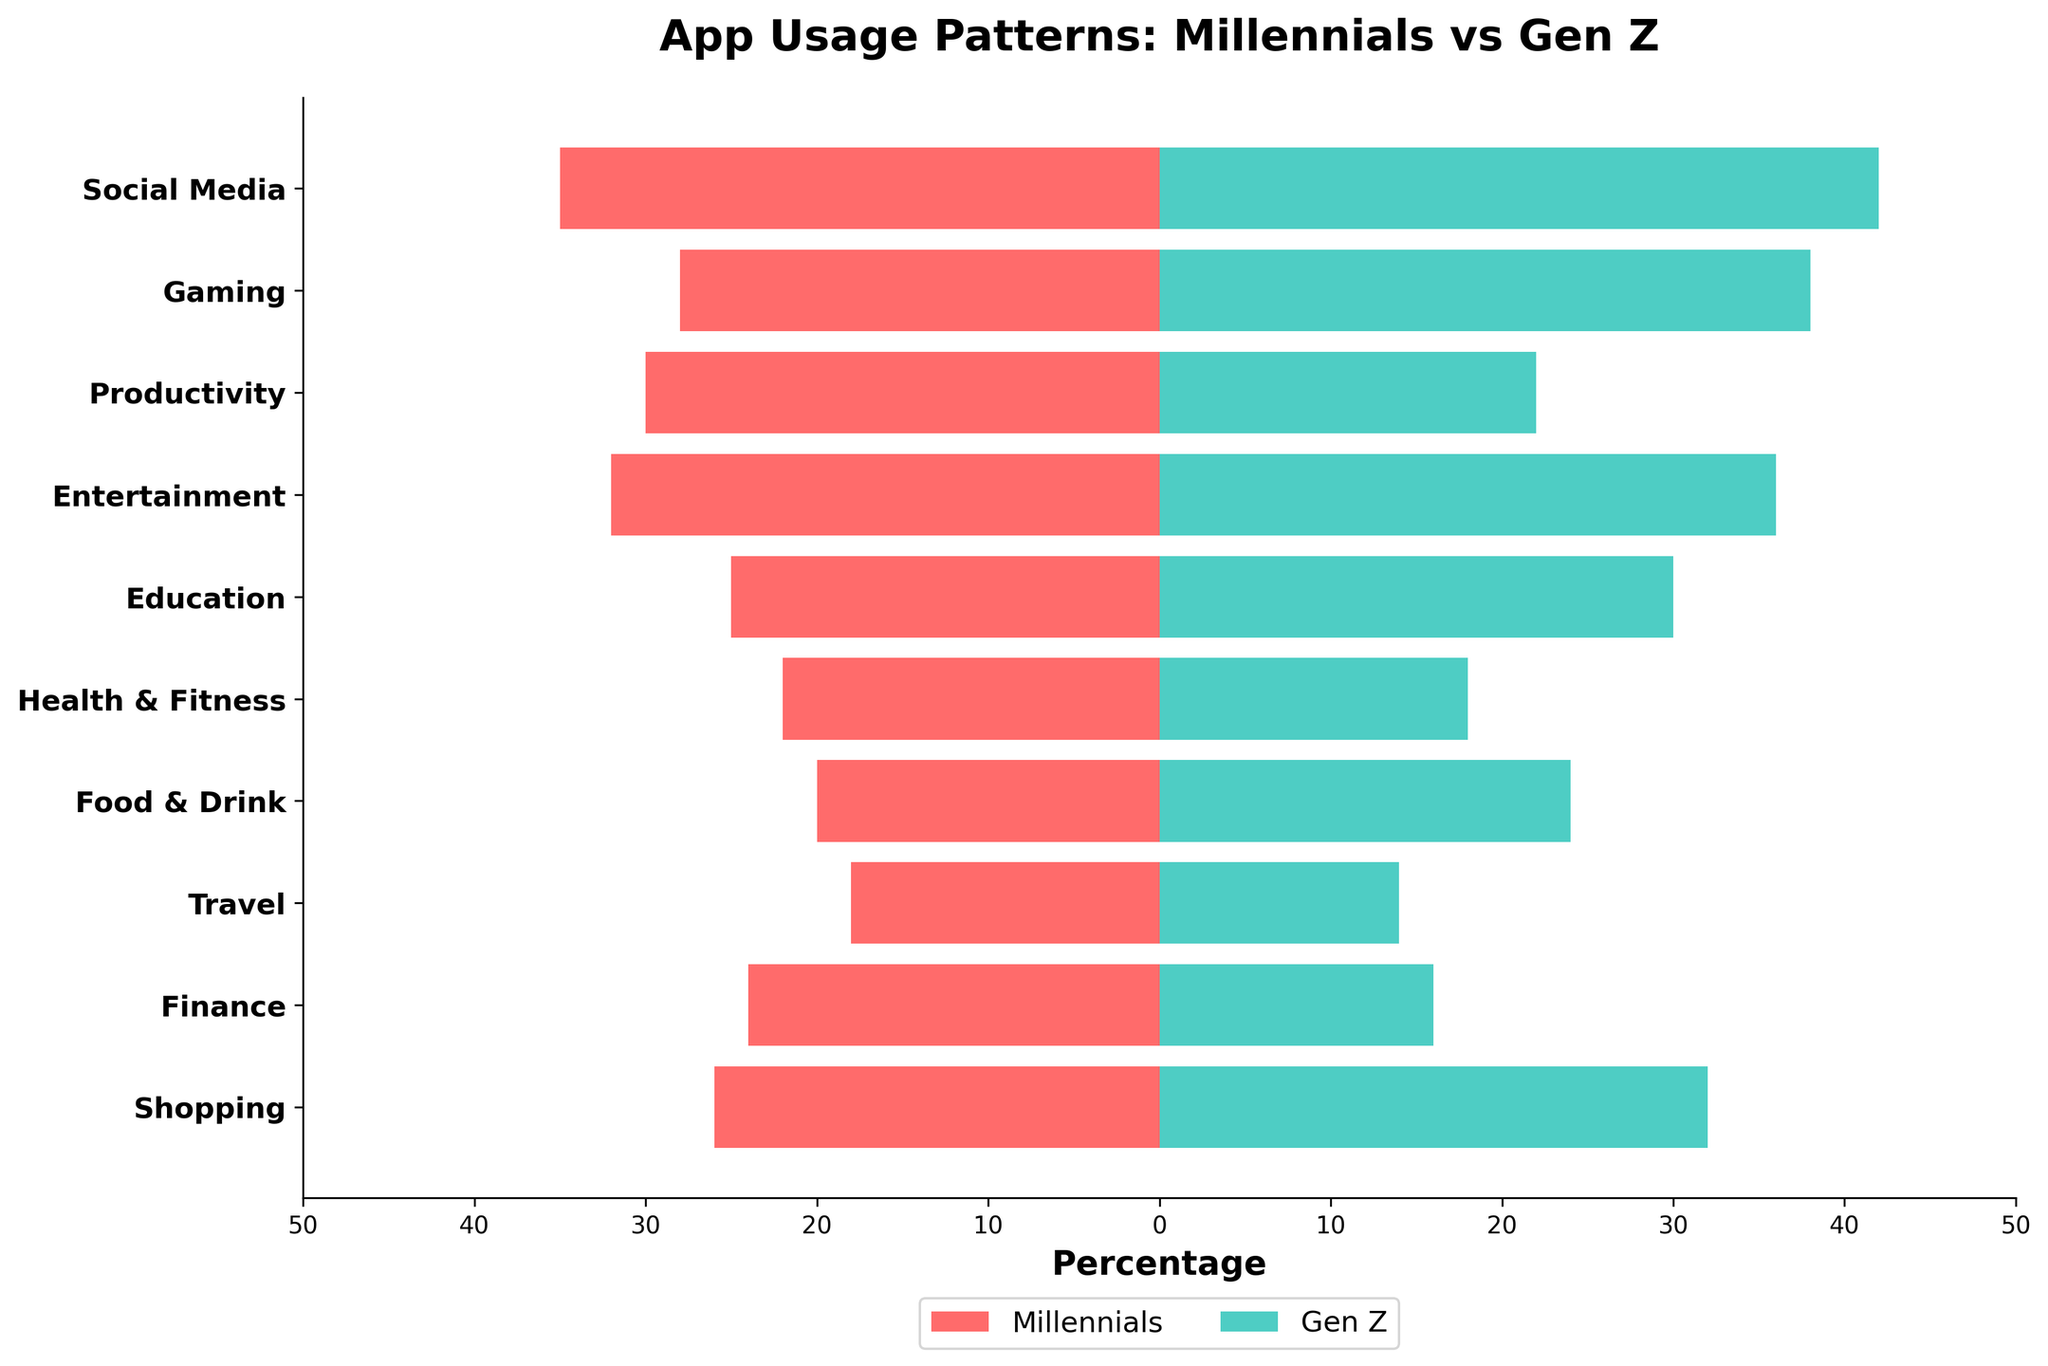What is the title of the figure? The title is typically located at the top of the figure, and it is designed to give an overview of what the figure is about. In this case, the title is "App Usage Patterns: Millennials vs Gen Z".
Answer: App Usage Patterns: Millennials vs Gen Z What are the two groups compared in the figure? The legend at the bottom of the chart indicates the two groups. Here, the groups compared are "Millennials" and "Gen Z".
Answer: Millennials and Gen Z Which app category shows the highest percentage of usage among Gen Z? To determine this, look at the bars representing Gen Z in the figure and find the longest bar. The "Social Media" category has the highest percentage of app usage among Gen Z with a value of 42%.
Answer: Social Media Which category has a greater difference in app usage between Millennials and Gen Z? Calculate the differences in usage percentages for each category: Social Media (42-35=7), Gaming (38-28=10), Productivity (30-22=8), Entertainment (36-32=4), Education (30-25=5), Health & Fitness (22-18=4), Food & Drink (24-20=4), Travel (18-14=4), Finance (24-16=8), Shopping (32-26=6). The greatest difference is in the Gaming category with a difference of 10%.
Answer: Gaming What is the average app usage percentage for Millennials across all categories? To find the average, sum all values for Millennials (35 + 28 + 30 + 32 + 25 + 22 + 20 + 18 + 24 + 26 = 260), then divide by the number of categories (10). The average is 260/10 = 26.
Answer: 26 Which categories have higher app usage percentages for Millennials compared to Gen Z? Compare the percentages for each category: Social Media (35 vs 42), Gaming (28 vs 38), Productivity (30 vs 22), Entertainment (32 vs 36), Education (25 vs 30), Health & Fitness (22 vs 18), Food & Drink (20 vs 24), Travel (18 vs 14), Finance (24 vs 16), Shopping (26 vs 32). Millennials have higher usage in Productivity (30 vs 22), Health & Fitness (22 vs 18), Travel (18 vs 14), and Finance (24 vs 16).
Answer: Productivity, Health & Fitness, Travel, Finance What is the combined percentage of app usage for the Health & Fitness category for both Millennials and Gen Z? Add the percentages for Health & Fitness for both groups: Millennials (22) and Gen Z (18). The combined percentage is 22 + 18 = 40.
Answer: 40 In which app category do Millennials have the lowest usage percentage? Identify the shortest bar for Millennials in the figure. The Travel category has the lowest usage percentage for Millennials with a value of 18%.
Answer: Travel 